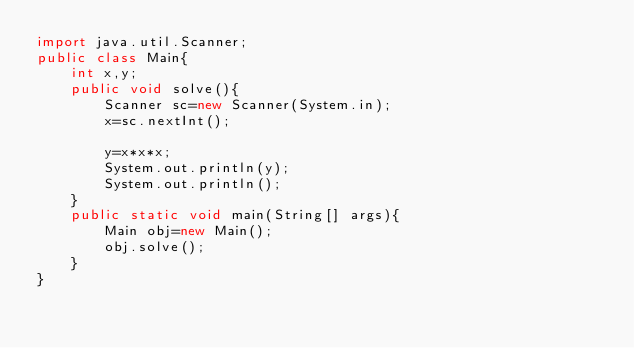<code> <loc_0><loc_0><loc_500><loc_500><_Java_>import java.util.Scanner;
public class Main{
	int x,y;
	public void solve(){
		Scanner sc=new Scanner(System.in);
		x=sc.nextInt();
		
		y=x*x*x;
		System.out.println(y);
		System.out.println();
	}
	public static void main(String[] args){
		Main obj=new Main();
		obj.solve();
	}
}</code> 